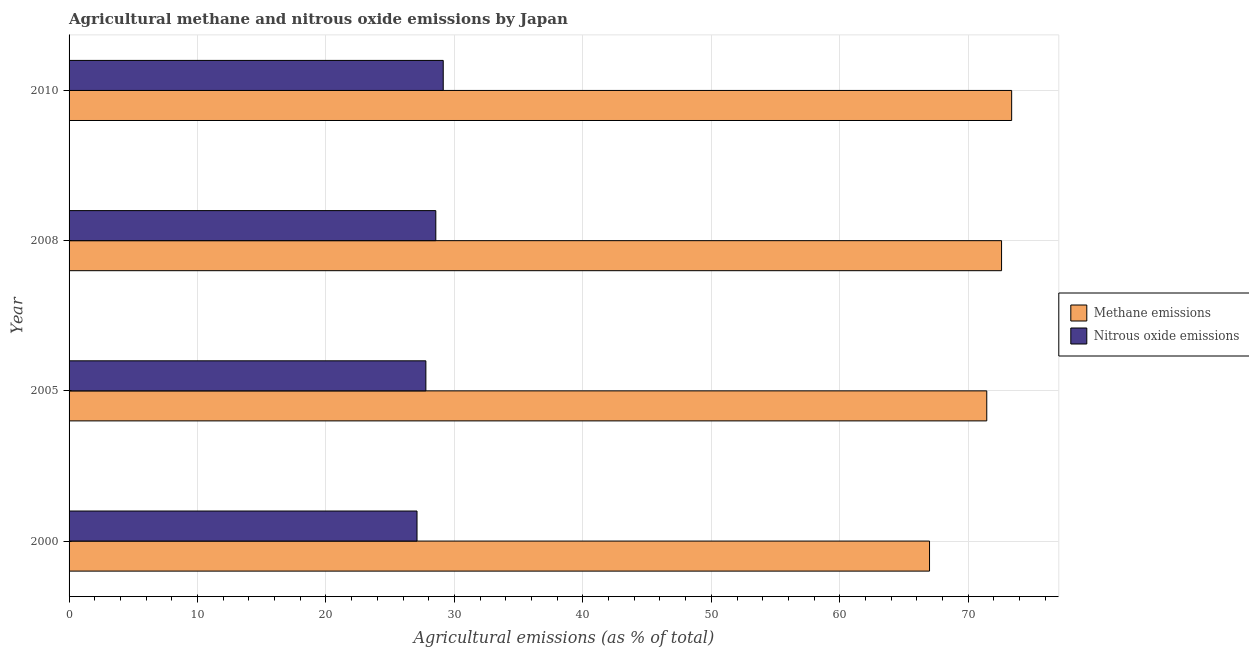How many different coloured bars are there?
Offer a terse response. 2. In how many cases, is the number of bars for a given year not equal to the number of legend labels?
Ensure brevity in your answer.  0. What is the amount of nitrous oxide emissions in 2000?
Ensure brevity in your answer.  27.09. Across all years, what is the maximum amount of nitrous oxide emissions?
Your response must be concise. 29.13. Across all years, what is the minimum amount of methane emissions?
Your response must be concise. 66.99. In which year was the amount of methane emissions minimum?
Make the answer very short. 2000. What is the total amount of nitrous oxide emissions in the graph?
Provide a short and direct response. 112.55. What is the difference between the amount of methane emissions in 2008 and that in 2010?
Offer a terse response. -0.79. What is the difference between the amount of nitrous oxide emissions in 2000 and the amount of methane emissions in 2010?
Make the answer very short. -46.29. What is the average amount of methane emissions per year?
Make the answer very short. 71.1. In the year 2010, what is the difference between the amount of nitrous oxide emissions and amount of methane emissions?
Make the answer very short. -44.25. In how many years, is the amount of methane emissions greater than 72 %?
Ensure brevity in your answer.  2. Is the difference between the amount of nitrous oxide emissions in 2000 and 2008 greater than the difference between the amount of methane emissions in 2000 and 2008?
Make the answer very short. Yes. What is the difference between the highest and the second highest amount of methane emissions?
Provide a succinct answer. 0.79. What is the difference between the highest and the lowest amount of methane emissions?
Your answer should be compact. 6.39. In how many years, is the amount of nitrous oxide emissions greater than the average amount of nitrous oxide emissions taken over all years?
Your answer should be compact. 2. Is the sum of the amount of nitrous oxide emissions in 2000 and 2010 greater than the maximum amount of methane emissions across all years?
Offer a very short reply. No. What does the 2nd bar from the top in 2008 represents?
Offer a very short reply. Methane emissions. What does the 1st bar from the bottom in 2005 represents?
Provide a short and direct response. Methane emissions. Are all the bars in the graph horizontal?
Make the answer very short. Yes. What is the difference between two consecutive major ticks on the X-axis?
Your answer should be very brief. 10. Are the values on the major ticks of X-axis written in scientific E-notation?
Provide a succinct answer. No. Does the graph contain any zero values?
Offer a very short reply. No. How many legend labels are there?
Provide a short and direct response. 2. How are the legend labels stacked?
Your answer should be very brief. Vertical. What is the title of the graph?
Make the answer very short. Agricultural methane and nitrous oxide emissions by Japan. Does "Public credit registry" appear as one of the legend labels in the graph?
Offer a very short reply. No. What is the label or title of the X-axis?
Offer a very short reply. Agricultural emissions (as % of total). What is the Agricultural emissions (as % of total) of Methane emissions in 2000?
Ensure brevity in your answer.  66.99. What is the Agricultural emissions (as % of total) of Nitrous oxide emissions in 2000?
Provide a succinct answer. 27.09. What is the Agricultural emissions (as % of total) of Methane emissions in 2005?
Ensure brevity in your answer.  71.44. What is the Agricultural emissions (as % of total) of Nitrous oxide emissions in 2005?
Your answer should be very brief. 27.78. What is the Agricultural emissions (as % of total) in Methane emissions in 2008?
Your answer should be very brief. 72.6. What is the Agricultural emissions (as % of total) in Nitrous oxide emissions in 2008?
Offer a terse response. 28.55. What is the Agricultural emissions (as % of total) of Methane emissions in 2010?
Keep it short and to the point. 73.38. What is the Agricultural emissions (as % of total) of Nitrous oxide emissions in 2010?
Your response must be concise. 29.13. Across all years, what is the maximum Agricultural emissions (as % of total) in Methane emissions?
Offer a terse response. 73.38. Across all years, what is the maximum Agricultural emissions (as % of total) in Nitrous oxide emissions?
Your response must be concise. 29.13. Across all years, what is the minimum Agricultural emissions (as % of total) in Methane emissions?
Provide a succinct answer. 66.99. Across all years, what is the minimum Agricultural emissions (as % of total) of Nitrous oxide emissions?
Offer a very short reply. 27.09. What is the total Agricultural emissions (as % of total) in Methane emissions in the graph?
Ensure brevity in your answer.  284.41. What is the total Agricultural emissions (as % of total) in Nitrous oxide emissions in the graph?
Offer a terse response. 112.55. What is the difference between the Agricultural emissions (as % of total) of Methane emissions in 2000 and that in 2005?
Provide a succinct answer. -4.46. What is the difference between the Agricultural emissions (as % of total) in Nitrous oxide emissions in 2000 and that in 2005?
Offer a very short reply. -0.69. What is the difference between the Agricultural emissions (as % of total) of Methane emissions in 2000 and that in 2008?
Your answer should be very brief. -5.61. What is the difference between the Agricultural emissions (as % of total) of Nitrous oxide emissions in 2000 and that in 2008?
Make the answer very short. -1.46. What is the difference between the Agricultural emissions (as % of total) of Methane emissions in 2000 and that in 2010?
Your response must be concise. -6.39. What is the difference between the Agricultural emissions (as % of total) of Nitrous oxide emissions in 2000 and that in 2010?
Provide a succinct answer. -2.04. What is the difference between the Agricultural emissions (as % of total) in Methane emissions in 2005 and that in 2008?
Provide a short and direct response. -1.15. What is the difference between the Agricultural emissions (as % of total) of Nitrous oxide emissions in 2005 and that in 2008?
Make the answer very short. -0.77. What is the difference between the Agricultural emissions (as % of total) in Methane emissions in 2005 and that in 2010?
Your response must be concise. -1.94. What is the difference between the Agricultural emissions (as % of total) of Nitrous oxide emissions in 2005 and that in 2010?
Keep it short and to the point. -1.35. What is the difference between the Agricultural emissions (as % of total) of Methane emissions in 2008 and that in 2010?
Your answer should be very brief. -0.79. What is the difference between the Agricultural emissions (as % of total) of Nitrous oxide emissions in 2008 and that in 2010?
Your response must be concise. -0.58. What is the difference between the Agricultural emissions (as % of total) of Methane emissions in 2000 and the Agricultural emissions (as % of total) of Nitrous oxide emissions in 2005?
Provide a short and direct response. 39.21. What is the difference between the Agricultural emissions (as % of total) of Methane emissions in 2000 and the Agricultural emissions (as % of total) of Nitrous oxide emissions in 2008?
Offer a terse response. 38.44. What is the difference between the Agricultural emissions (as % of total) in Methane emissions in 2000 and the Agricultural emissions (as % of total) in Nitrous oxide emissions in 2010?
Give a very brief answer. 37.86. What is the difference between the Agricultural emissions (as % of total) of Methane emissions in 2005 and the Agricultural emissions (as % of total) of Nitrous oxide emissions in 2008?
Give a very brief answer. 42.89. What is the difference between the Agricultural emissions (as % of total) of Methane emissions in 2005 and the Agricultural emissions (as % of total) of Nitrous oxide emissions in 2010?
Keep it short and to the point. 42.31. What is the difference between the Agricultural emissions (as % of total) in Methane emissions in 2008 and the Agricultural emissions (as % of total) in Nitrous oxide emissions in 2010?
Keep it short and to the point. 43.47. What is the average Agricultural emissions (as % of total) in Methane emissions per year?
Your answer should be very brief. 71.1. What is the average Agricultural emissions (as % of total) in Nitrous oxide emissions per year?
Ensure brevity in your answer.  28.14. In the year 2000, what is the difference between the Agricultural emissions (as % of total) in Methane emissions and Agricultural emissions (as % of total) in Nitrous oxide emissions?
Provide a succinct answer. 39.9. In the year 2005, what is the difference between the Agricultural emissions (as % of total) in Methane emissions and Agricultural emissions (as % of total) in Nitrous oxide emissions?
Give a very brief answer. 43.67. In the year 2008, what is the difference between the Agricultural emissions (as % of total) of Methane emissions and Agricultural emissions (as % of total) of Nitrous oxide emissions?
Ensure brevity in your answer.  44.05. In the year 2010, what is the difference between the Agricultural emissions (as % of total) of Methane emissions and Agricultural emissions (as % of total) of Nitrous oxide emissions?
Provide a succinct answer. 44.25. What is the ratio of the Agricultural emissions (as % of total) in Methane emissions in 2000 to that in 2005?
Your answer should be very brief. 0.94. What is the ratio of the Agricultural emissions (as % of total) of Nitrous oxide emissions in 2000 to that in 2005?
Your answer should be very brief. 0.98. What is the ratio of the Agricultural emissions (as % of total) of Methane emissions in 2000 to that in 2008?
Provide a succinct answer. 0.92. What is the ratio of the Agricultural emissions (as % of total) in Nitrous oxide emissions in 2000 to that in 2008?
Keep it short and to the point. 0.95. What is the ratio of the Agricultural emissions (as % of total) in Methane emissions in 2000 to that in 2010?
Your response must be concise. 0.91. What is the ratio of the Agricultural emissions (as % of total) of Nitrous oxide emissions in 2000 to that in 2010?
Offer a very short reply. 0.93. What is the ratio of the Agricultural emissions (as % of total) of Methane emissions in 2005 to that in 2008?
Give a very brief answer. 0.98. What is the ratio of the Agricultural emissions (as % of total) of Nitrous oxide emissions in 2005 to that in 2008?
Offer a very short reply. 0.97. What is the ratio of the Agricultural emissions (as % of total) of Methane emissions in 2005 to that in 2010?
Make the answer very short. 0.97. What is the ratio of the Agricultural emissions (as % of total) of Nitrous oxide emissions in 2005 to that in 2010?
Keep it short and to the point. 0.95. What is the ratio of the Agricultural emissions (as % of total) of Methane emissions in 2008 to that in 2010?
Offer a very short reply. 0.99. What is the ratio of the Agricultural emissions (as % of total) in Nitrous oxide emissions in 2008 to that in 2010?
Your response must be concise. 0.98. What is the difference between the highest and the second highest Agricultural emissions (as % of total) of Methane emissions?
Give a very brief answer. 0.79. What is the difference between the highest and the second highest Agricultural emissions (as % of total) of Nitrous oxide emissions?
Provide a succinct answer. 0.58. What is the difference between the highest and the lowest Agricultural emissions (as % of total) of Methane emissions?
Provide a succinct answer. 6.39. What is the difference between the highest and the lowest Agricultural emissions (as % of total) of Nitrous oxide emissions?
Provide a short and direct response. 2.04. 